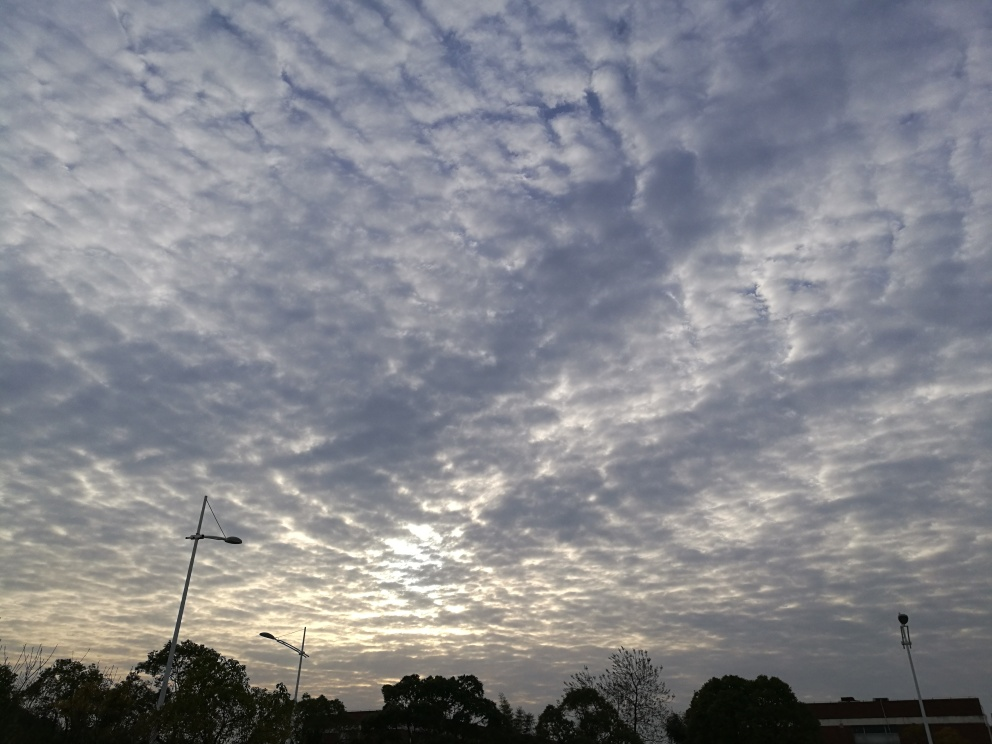Are there any quality issues with this image? Yes, upon inspection, the image appears to have slightly low lighting which may affect the visibility of certain details, particularly in the darker areas. Additionally, there is a noticeable tilt to the right, which could be corrected for a more balanced composition. However, the image is still clear enough to make out the patterns of the clouds quite distinctly. 